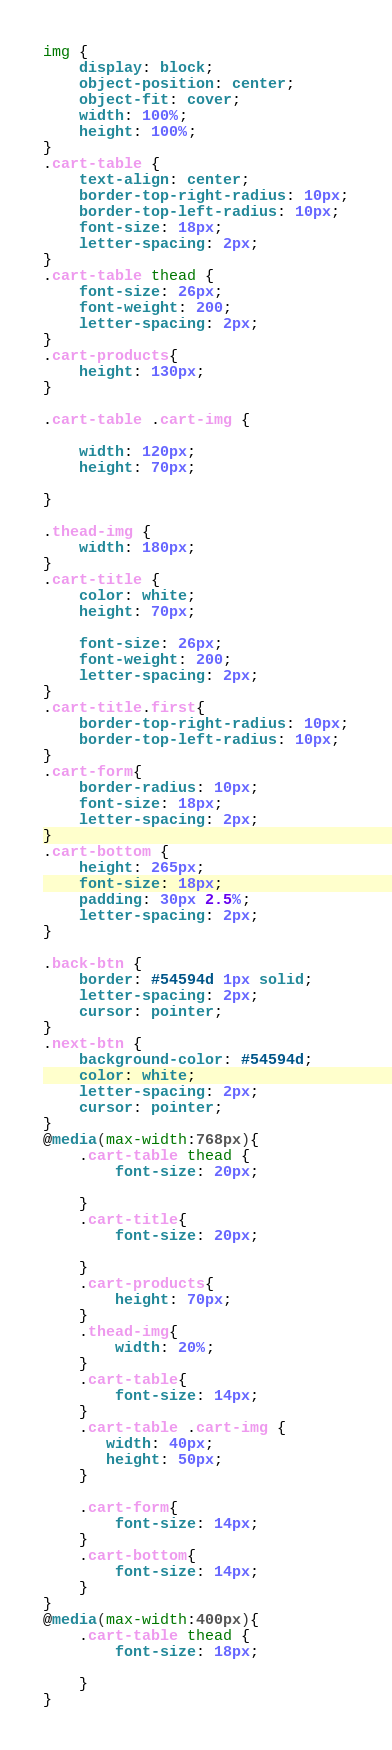<code> <loc_0><loc_0><loc_500><loc_500><_CSS_>img {
    display: block;
    object-position: center;
    object-fit: cover;
    width: 100%;
    height: 100%;
}
.cart-table {
    text-align: center;
    border-top-right-radius: 10px;
    border-top-left-radius: 10px;
    font-size: 18px;
    letter-spacing: 2px;
}
.cart-table thead {
    font-size: 26px;
    font-weight: 200;
    letter-spacing: 2px;
}
.cart-products{
    height: 130px;
}

.cart-table .cart-img {

    width: 120px;
    height: 70px;

}

.thead-img {
    width: 180px;
}
.cart-title {
    color: white;
    height: 70px;

    font-size: 26px;
    font-weight: 200;
    letter-spacing: 2px;
}
.cart-title.first{
    border-top-right-radius: 10px;
    border-top-left-radius: 10px;
}
.cart-form{
    border-radius: 10px;
    font-size: 18px;
    letter-spacing: 2px;
}
.cart-bottom {
    height: 265px;
    font-size: 18px;
    padding: 30px 2.5%;
    letter-spacing: 2px;
}

.back-btn {
    border: #54594d 1px solid;
    letter-spacing: 2px;
    cursor: pointer;
}
.next-btn {
    background-color: #54594d;
    color: white;
    letter-spacing: 2px;
    cursor: pointer;
}
@media(max-width:768px){
    .cart-table thead {
        font-size: 20px;

    }
    .cart-title{
        font-size: 20px;

    }
    .cart-products{
        height: 70px;
    }
    .thead-img{
        width: 20%;
    }
    .cart-table{
        font-size: 14px;
    }
    .cart-table .cart-img {
       width: 40px;
       height: 50px;
    }

    .cart-form{
        font-size: 14px;
    }
    .cart-bottom{
        font-size: 14px;
    }
}
@media(max-width:400px){
    .cart-table thead {
        font-size: 18px;

    }
}
</code> 